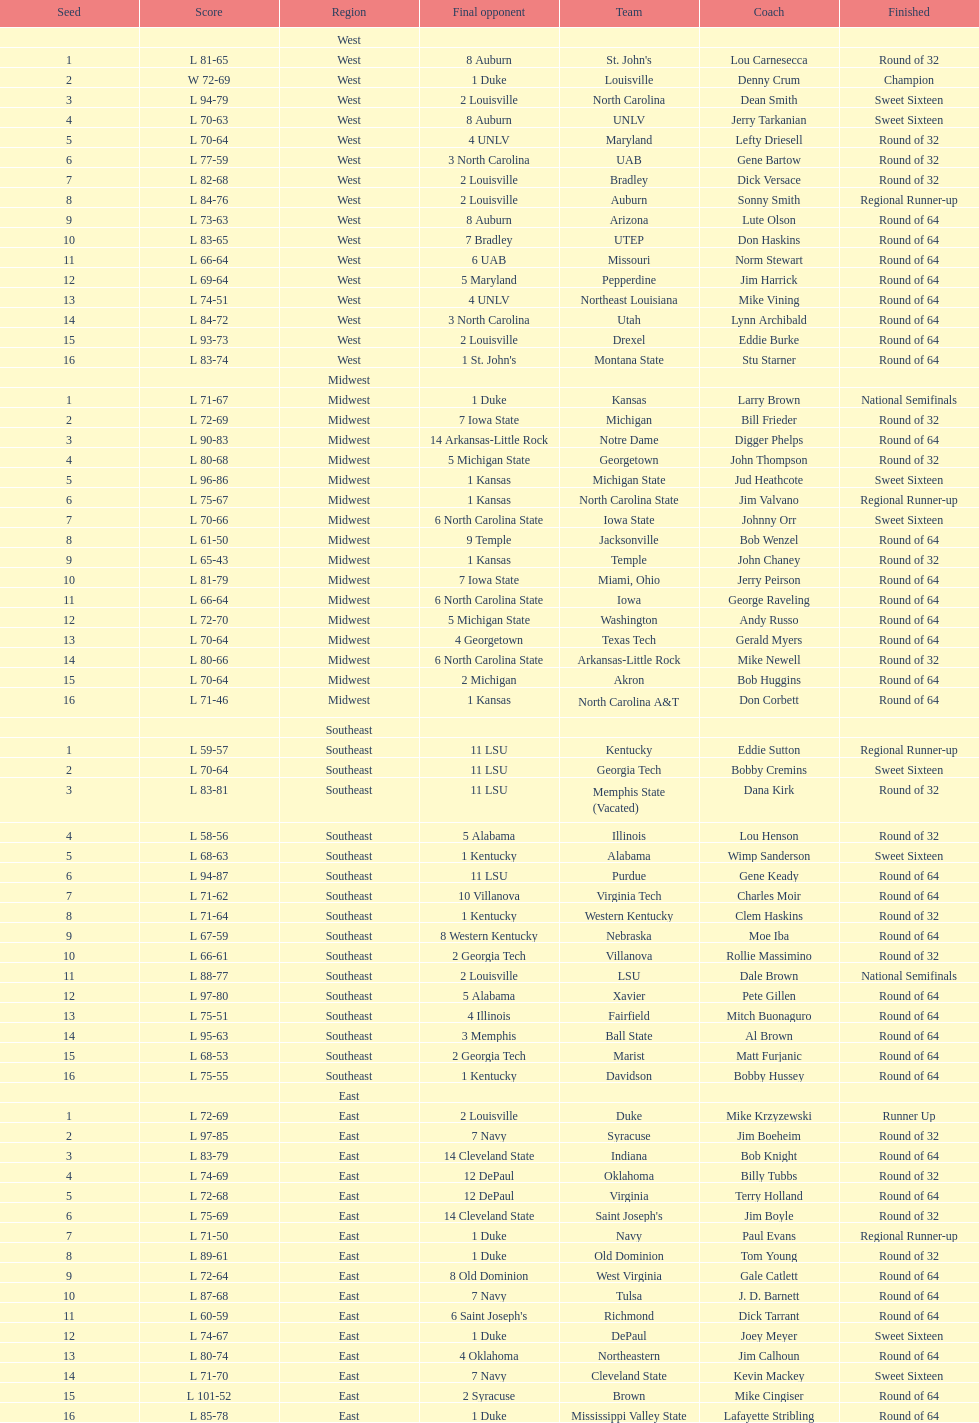What region is listed before the midwest? West. Could you parse the entire table? {'header': ['Seed', 'Score', 'Region', 'Final opponent', 'Team', 'Coach', 'Finished'], 'rows': [['', '', 'West', '', '', '', ''], ['1', 'L 81-65', 'West', '8 Auburn', "St. John's", 'Lou Carnesecca', 'Round of 32'], ['2', 'W 72-69', 'West', '1 Duke', 'Louisville', 'Denny Crum', 'Champion'], ['3', 'L 94-79', 'West', '2 Louisville', 'North Carolina', 'Dean Smith', 'Sweet Sixteen'], ['4', 'L 70-63', 'West', '8 Auburn', 'UNLV', 'Jerry Tarkanian', 'Sweet Sixteen'], ['5', 'L 70-64', 'West', '4 UNLV', 'Maryland', 'Lefty Driesell', 'Round of 32'], ['6', 'L 77-59', 'West', '3 North Carolina', 'UAB', 'Gene Bartow', 'Round of 32'], ['7', 'L 82-68', 'West', '2 Louisville', 'Bradley', 'Dick Versace', 'Round of 32'], ['8', 'L 84-76', 'West', '2 Louisville', 'Auburn', 'Sonny Smith', 'Regional Runner-up'], ['9', 'L 73-63', 'West', '8 Auburn', 'Arizona', 'Lute Olson', 'Round of 64'], ['10', 'L 83-65', 'West', '7 Bradley', 'UTEP', 'Don Haskins', 'Round of 64'], ['11', 'L 66-64', 'West', '6 UAB', 'Missouri', 'Norm Stewart', 'Round of 64'], ['12', 'L 69-64', 'West', '5 Maryland', 'Pepperdine', 'Jim Harrick', 'Round of 64'], ['13', 'L 74-51', 'West', '4 UNLV', 'Northeast Louisiana', 'Mike Vining', 'Round of 64'], ['14', 'L 84-72', 'West', '3 North Carolina', 'Utah', 'Lynn Archibald', 'Round of 64'], ['15', 'L 93-73', 'West', '2 Louisville', 'Drexel', 'Eddie Burke', 'Round of 64'], ['16', 'L 83-74', 'West', "1 St. John's", 'Montana State', 'Stu Starner', 'Round of 64'], ['', '', 'Midwest', '', '', '', ''], ['1', 'L 71-67', 'Midwest', '1 Duke', 'Kansas', 'Larry Brown', 'National Semifinals'], ['2', 'L 72-69', 'Midwest', '7 Iowa State', 'Michigan', 'Bill Frieder', 'Round of 32'], ['3', 'L 90-83', 'Midwest', '14 Arkansas-Little Rock', 'Notre Dame', 'Digger Phelps', 'Round of 64'], ['4', 'L 80-68', 'Midwest', '5 Michigan State', 'Georgetown', 'John Thompson', 'Round of 32'], ['5', 'L 96-86', 'Midwest', '1 Kansas', 'Michigan State', 'Jud Heathcote', 'Sweet Sixteen'], ['6', 'L 75-67', 'Midwest', '1 Kansas', 'North Carolina State', 'Jim Valvano', 'Regional Runner-up'], ['7', 'L 70-66', 'Midwest', '6 North Carolina State', 'Iowa State', 'Johnny Orr', 'Sweet Sixteen'], ['8', 'L 61-50', 'Midwest', '9 Temple', 'Jacksonville', 'Bob Wenzel', 'Round of 64'], ['9', 'L 65-43', 'Midwest', '1 Kansas', 'Temple', 'John Chaney', 'Round of 32'], ['10', 'L 81-79', 'Midwest', '7 Iowa State', 'Miami, Ohio', 'Jerry Peirson', 'Round of 64'], ['11', 'L 66-64', 'Midwest', '6 North Carolina State', 'Iowa', 'George Raveling', 'Round of 64'], ['12', 'L 72-70', 'Midwest', '5 Michigan State', 'Washington', 'Andy Russo', 'Round of 64'], ['13', 'L 70-64', 'Midwest', '4 Georgetown', 'Texas Tech', 'Gerald Myers', 'Round of 64'], ['14', 'L 80-66', 'Midwest', '6 North Carolina State', 'Arkansas-Little Rock', 'Mike Newell', 'Round of 32'], ['15', 'L 70-64', 'Midwest', '2 Michigan', 'Akron', 'Bob Huggins', 'Round of 64'], ['16', 'L 71-46', 'Midwest', '1 Kansas', 'North Carolina A&T', 'Don Corbett', 'Round of 64'], ['', '', 'Southeast', '', '', '', ''], ['1', 'L 59-57', 'Southeast', '11 LSU', 'Kentucky', 'Eddie Sutton', 'Regional Runner-up'], ['2', 'L 70-64', 'Southeast', '11 LSU', 'Georgia Tech', 'Bobby Cremins', 'Sweet Sixteen'], ['3', 'L 83-81', 'Southeast', '11 LSU', 'Memphis State (Vacated)', 'Dana Kirk', 'Round of 32'], ['4', 'L 58-56', 'Southeast', '5 Alabama', 'Illinois', 'Lou Henson', 'Round of 32'], ['5', 'L 68-63', 'Southeast', '1 Kentucky', 'Alabama', 'Wimp Sanderson', 'Sweet Sixteen'], ['6', 'L 94-87', 'Southeast', '11 LSU', 'Purdue', 'Gene Keady', 'Round of 64'], ['7', 'L 71-62', 'Southeast', '10 Villanova', 'Virginia Tech', 'Charles Moir', 'Round of 64'], ['8', 'L 71-64', 'Southeast', '1 Kentucky', 'Western Kentucky', 'Clem Haskins', 'Round of 32'], ['9', 'L 67-59', 'Southeast', '8 Western Kentucky', 'Nebraska', 'Moe Iba', 'Round of 64'], ['10', 'L 66-61', 'Southeast', '2 Georgia Tech', 'Villanova', 'Rollie Massimino', 'Round of 32'], ['11', 'L 88-77', 'Southeast', '2 Louisville', 'LSU', 'Dale Brown', 'National Semifinals'], ['12', 'L 97-80', 'Southeast', '5 Alabama', 'Xavier', 'Pete Gillen', 'Round of 64'], ['13', 'L 75-51', 'Southeast', '4 Illinois', 'Fairfield', 'Mitch Buonaguro', 'Round of 64'], ['14', 'L 95-63', 'Southeast', '3 Memphis', 'Ball State', 'Al Brown', 'Round of 64'], ['15', 'L 68-53', 'Southeast', '2 Georgia Tech', 'Marist', 'Matt Furjanic', 'Round of 64'], ['16', 'L 75-55', 'Southeast', '1 Kentucky', 'Davidson', 'Bobby Hussey', 'Round of 64'], ['', '', 'East', '', '', '', ''], ['1', 'L 72-69', 'East', '2 Louisville', 'Duke', 'Mike Krzyzewski', 'Runner Up'], ['2', 'L 97-85', 'East', '7 Navy', 'Syracuse', 'Jim Boeheim', 'Round of 32'], ['3', 'L 83-79', 'East', '14 Cleveland State', 'Indiana', 'Bob Knight', 'Round of 64'], ['4', 'L 74-69', 'East', '12 DePaul', 'Oklahoma', 'Billy Tubbs', 'Round of 32'], ['5', 'L 72-68', 'East', '12 DePaul', 'Virginia', 'Terry Holland', 'Round of 64'], ['6', 'L 75-69', 'East', '14 Cleveland State', "Saint Joseph's", 'Jim Boyle', 'Round of 32'], ['7', 'L 71-50', 'East', '1 Duke', 'Navy', 'Paul Evans', 'Regional Runner-up'], ['8', 'L 89-61', 'East', '1 Duke', 'Old Dominion', 'Tom Young', 'Round of 32'], ['9', 'L 72-64', 'East', '8 Old Dominion', 'West Virginia', 'Gale Catlett', 'Round of 64'], ['10', 'L 87-68', 'East', '7 Navy', 'Tulsa', 'J. D. Barnett', 'Round of 64'], ['11', 'L 60-59', 'East', "6 Saint Joseph's", 'Richmond', 'Dick Tarrant', 'Round of 64'], ['12', 'L 74-67', 'East', '1 Duke', 'DePaul', 'Joey Meyer', 'Sweet Sixteen'], ['13', 'L 80-74', 'East', '4 Oklahoma', 'Northeastern', 'Jim Calhoun', 'Round of 64'], ['14', 'L 71-70', 'East', '7 Navy', 'Cleveland State', 'Kevin Mackey', 'Sweet Sixteen'], ['15', 'L 101-52', 'East', '2 Syracuse', 'Brown', 'Mike Cingiser', 'Round of 64'], ['16', 'L 85-78', 'East', '1 Duke', 'Mississippi Valley State', 'Lafayette Stribling', 'Round of 64']]} 